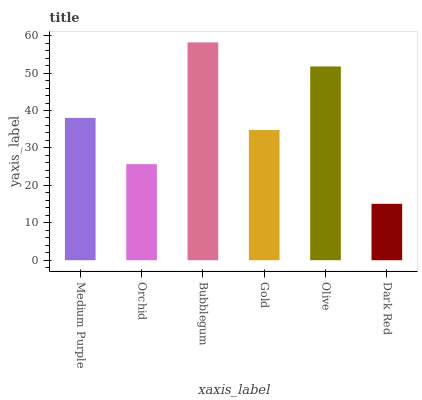Is Dark Red the minimum?
Answer yes or no. Yes. Is Bubblegum the maximum?
Answer yes or no. Yes. Is Orchid the minimum?
Answer yes or no. No. Is Orchid the maximum?
Answer yes or no. No. Is Medium Purple greater than Orchid?
Answer yes or no. Yes. Is Orchid less than Medium Purple?
Answer yes or no. Yes. Is Orchid greater than Medium Purple?
Answer yes or no. No. Is Medium Purple less than Orchid?
Answer yes or no. No. Is Medium Purple the high median?
Answer yes or no. Yes. Is Gold the low median?
Answer yes or no. Yes. Is Gold the high median?
Answer yes or no. No. Is Bubblegum the low median?
Answer yes or no. No. 